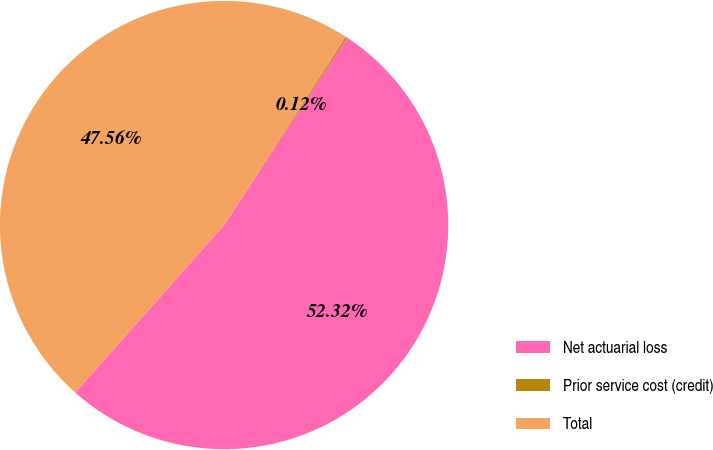<chart> <loc_0><loc_0><loc_500><loc_500><pie_chart><fcel>Net actuarial loss<fcel>Prior service cost (credit)<fcel>Total<nl><fcel>52.32%<fcel>0.12%<fcel>47.56%<nl></chart> 